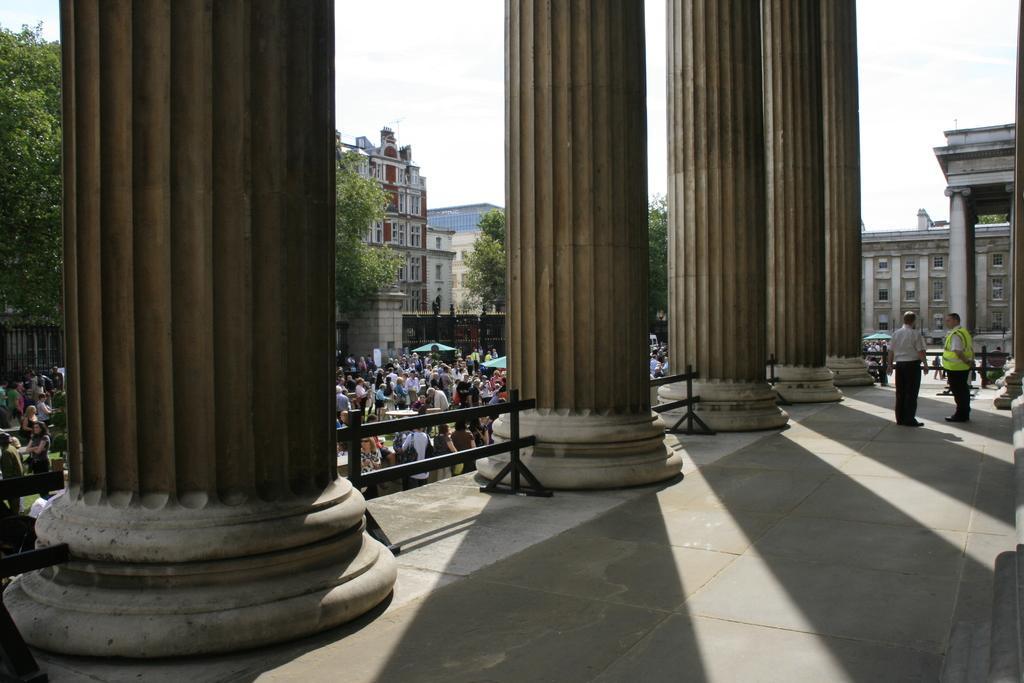In one or two sentences, can you explain what this image depicts? In this image we can see pillars with railings. Also there are many people. In the back there are many buildings with windows and there are trees. In the background there is sky. 